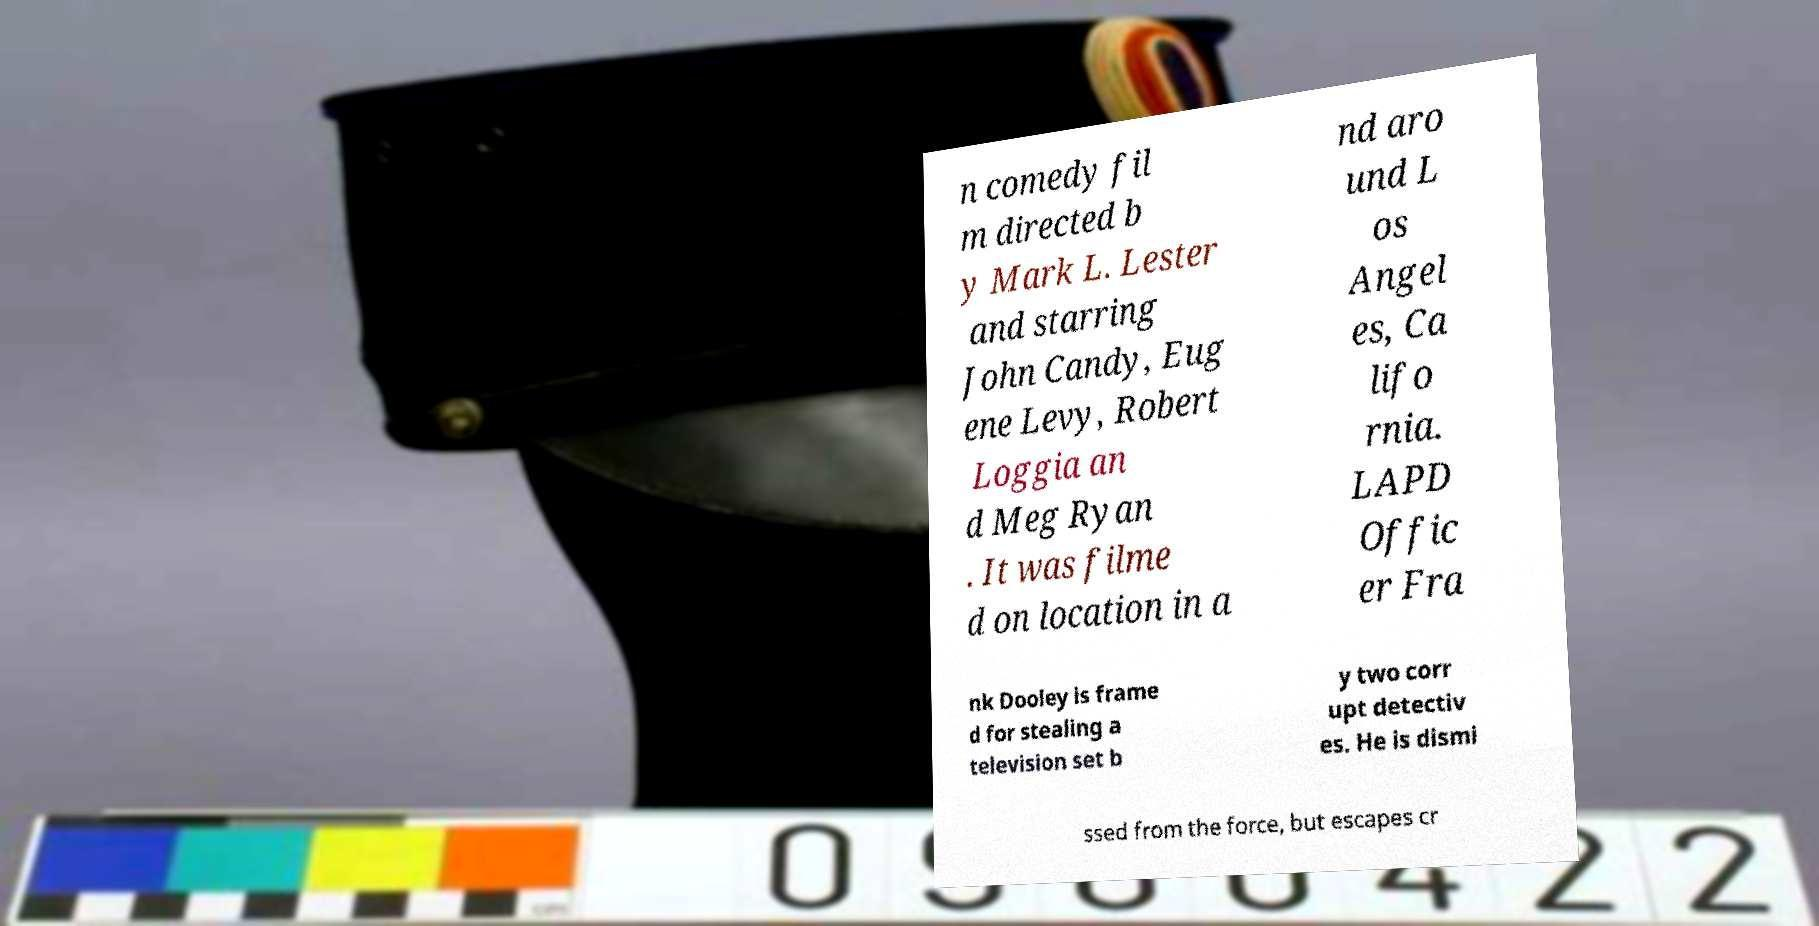Please read and relay the text visible in this image. What does it say? n comedy fil m directed b y Mark L. Lester and starring John Candy, Eug ene Levy, Robert Loggia an d Meg Ryan . It was filme d on location in a nd aro und L os Angel es, Ca lifo rnia. LAPD Offic er Fra nk Dooley is frame d for stealing a television set b y two corr upt detectiv es. He is dismi ssed from the force, but escapes cr 